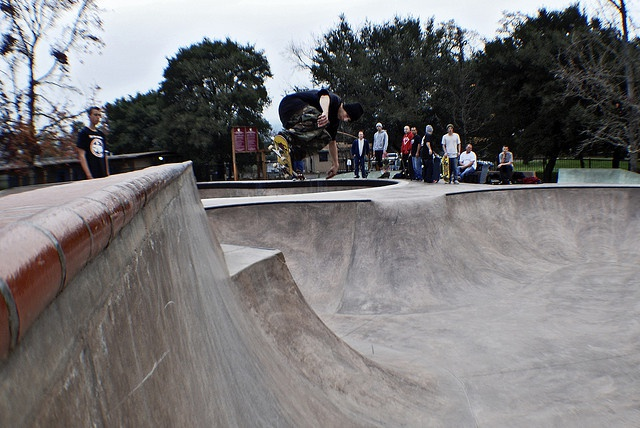Describe the objects in this image and their specific colors. I can see people in gray, black, maroon, and navy tones, people in gray, black, and maroon tones, people in gray, black, lightgray, and darkgray tones, people in gray, black, and darkgray tones, and bench in gray, black, and darkgray tones in this image. 